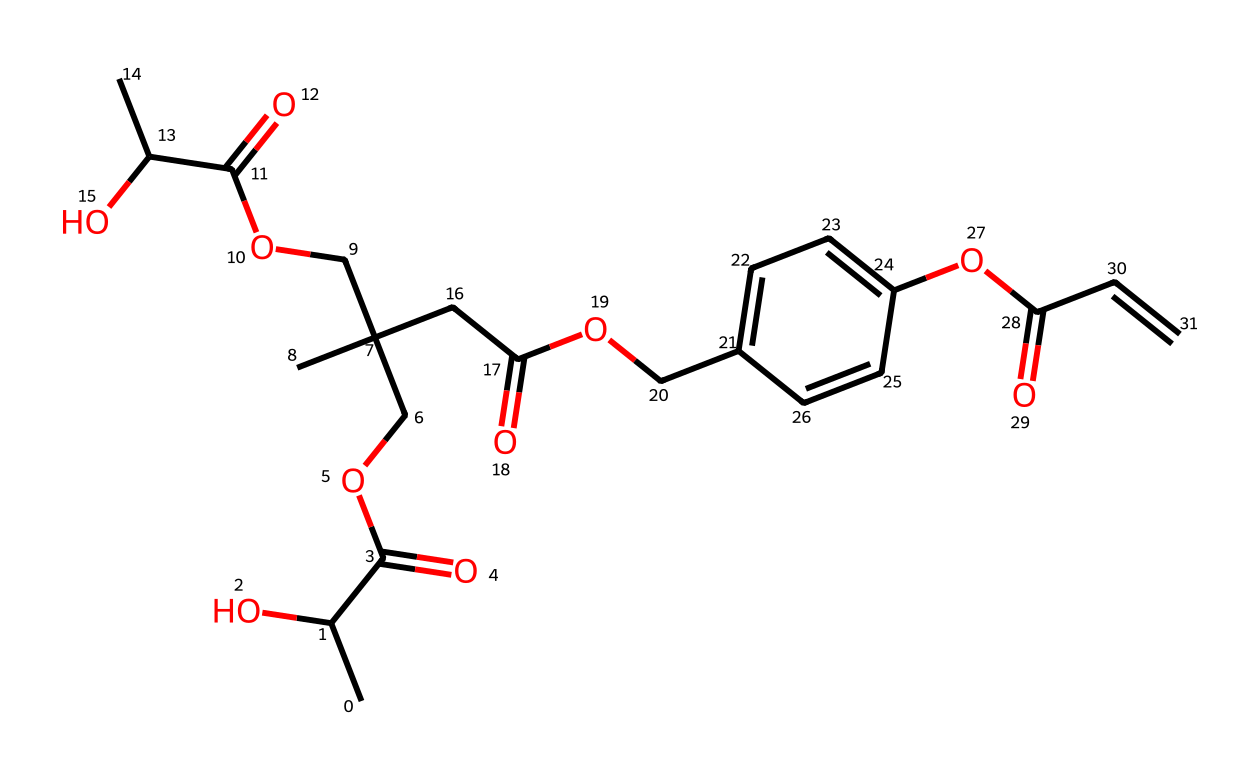What is the main functional group present in this chemical? The structure depends on the presence of carboxylic acid groups (-COOH), which are identifiable at different sites in the chemical representation.
Answer: carboxylic acid How many carbon atoms does this chemical have? Counting all the carbon atoms represented in the SMILES notation allows us to determine that there are 20 carbon atoms total in the structure.
Answer: 20 Does this chemical structure contain any aromatic rings? Identifying a ring with alternating single and double bonds can confirm the presence of an aromatic structure; in this case, there is one benzene ring noted in the chemical.
Answer: yes What type of polymer is used as the basis for this photoresist? The presence of “polylactic acid derivatives” within the name indicates that the polymer backbone is derived from lactic acid, a biodegradable biopolymer.
Answer: polylactic acid Which feature of this photoresist indicates its environmental friendliness? Biodegradable characteristics of polylactic acid and its derivatives suggest the eco-friendly nature of the material, evident from the entire structure being based on these derivatives.
Answer: biodegradability What is the purpose of adding aromatic components in this photoresist? Aromatic components often enhance the mechanical properties and stability of photoresists, contributing to their effectiveness when exposed to light.
Answer: stability 